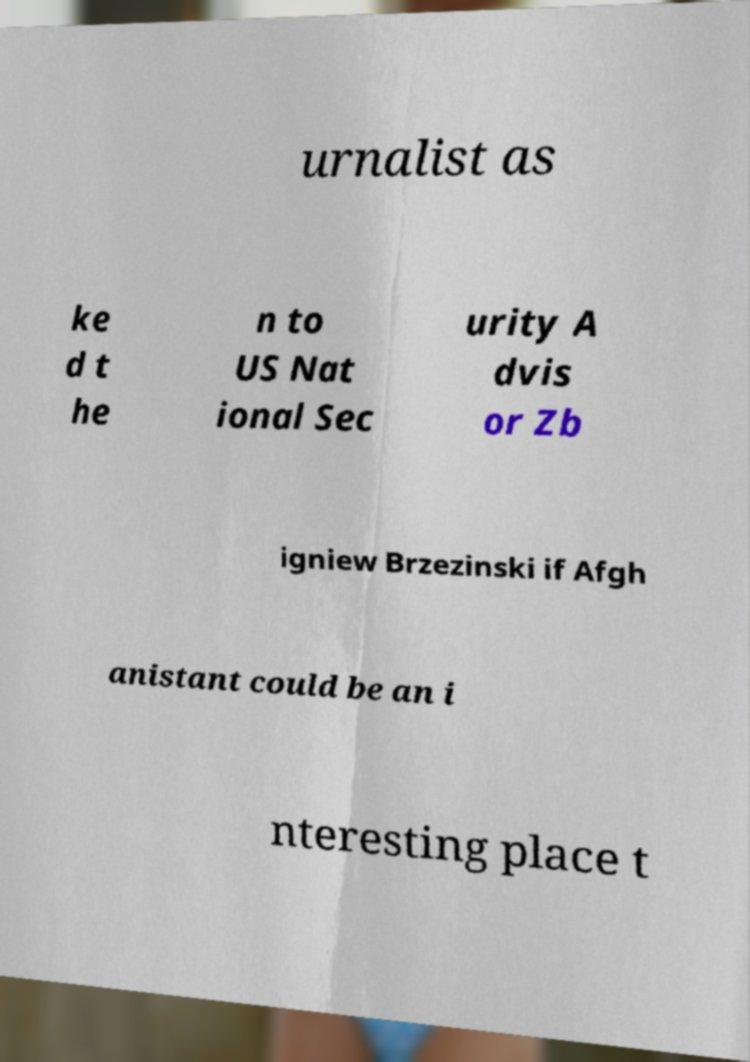Could you extract and type out the text from this image? urnalist as ke d t he n to US Nat ional Sec urity A dvis or Zb igniew Brzezinski if Afgh anistant could be an i nteresting place t 